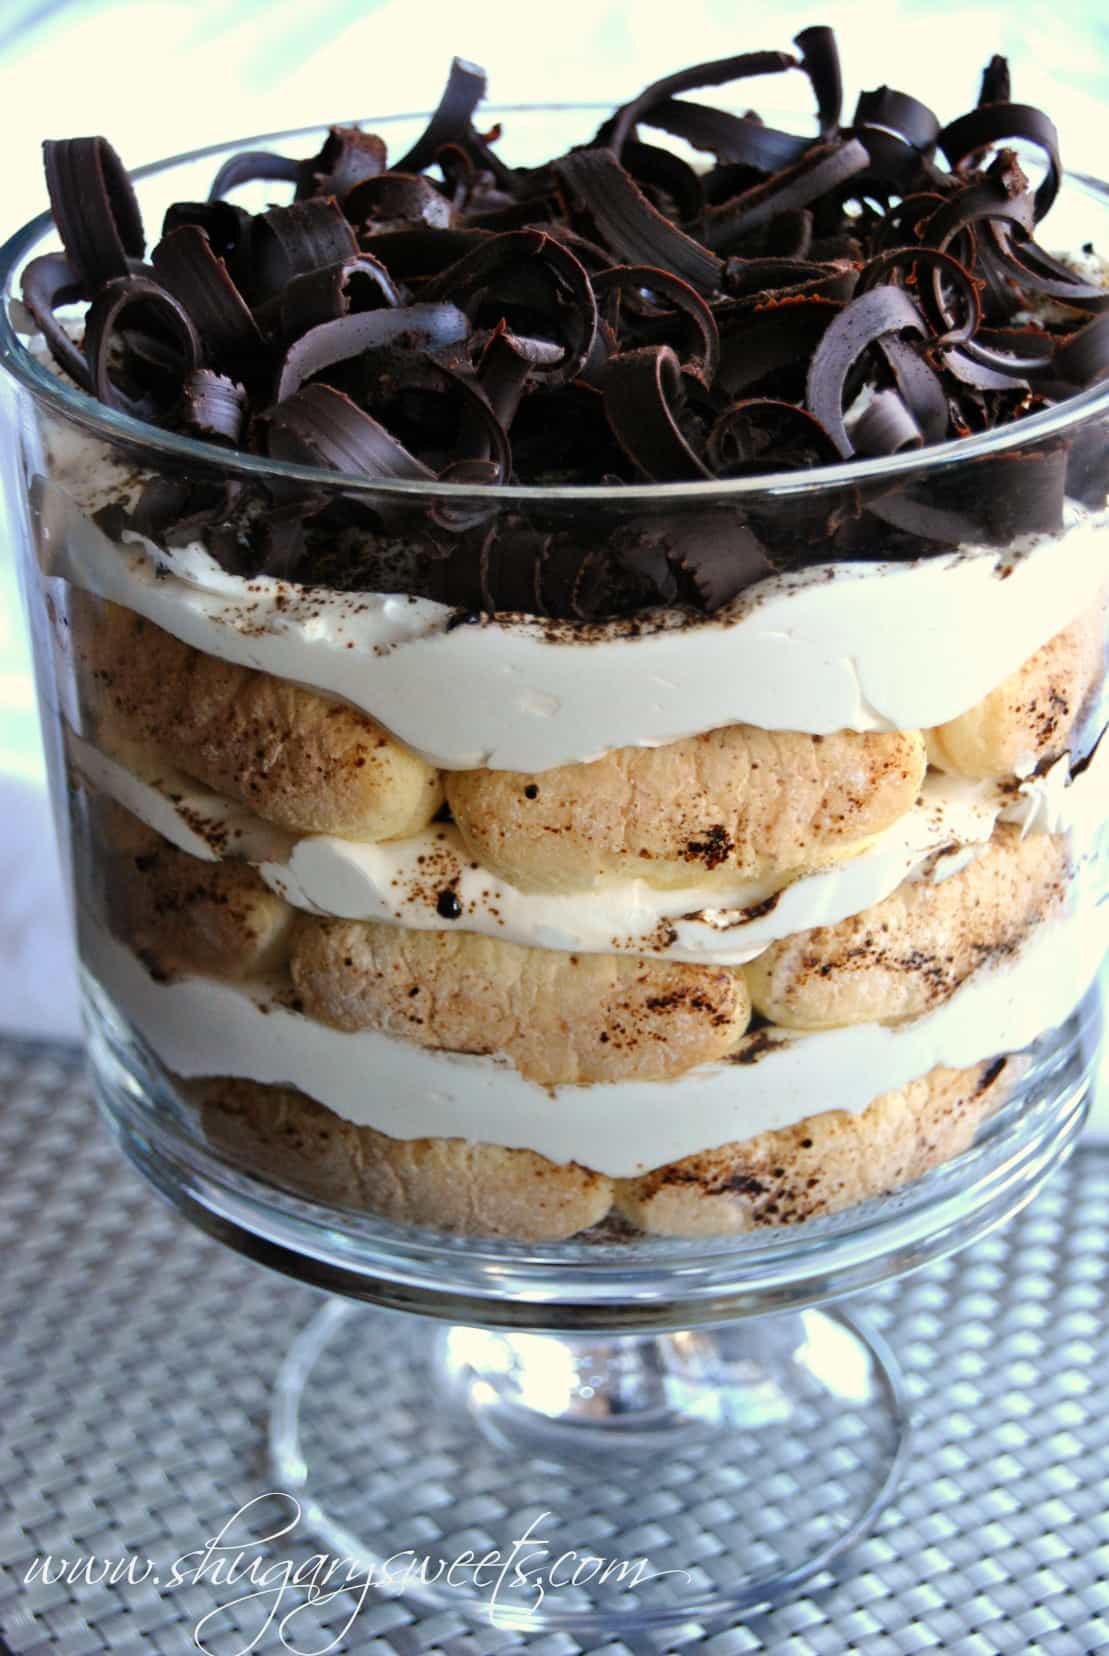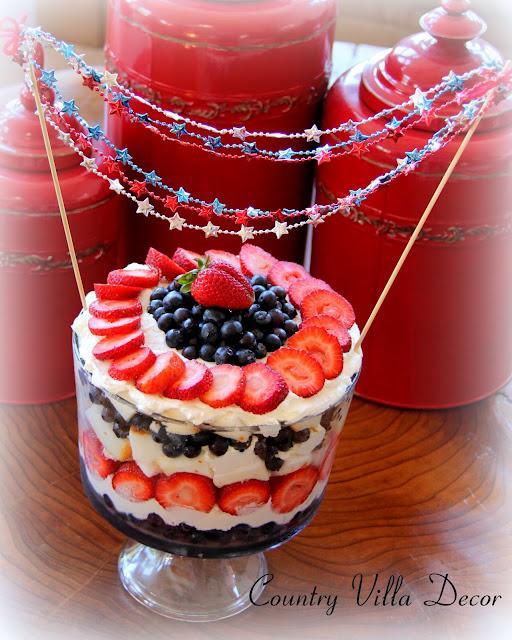The first image is the image on the left, the second image is the image on the right. Evaluate the accuracy of this statement regarding the images: "in one of the images, there is a strawberry nestled on top of a pile of blueberries on a cake". Is it true? Answer yes or no. Yes. The first image is the image on the left, the second image is the image on the right. Examine the images to the left and right. Is the description "In one image, a large dessert in a clear footed bowl is topped with a whole strawberry centered on a mound of blueberries, which are ringed by strawberry slices." accurate? Answer yes or no. Yes. 